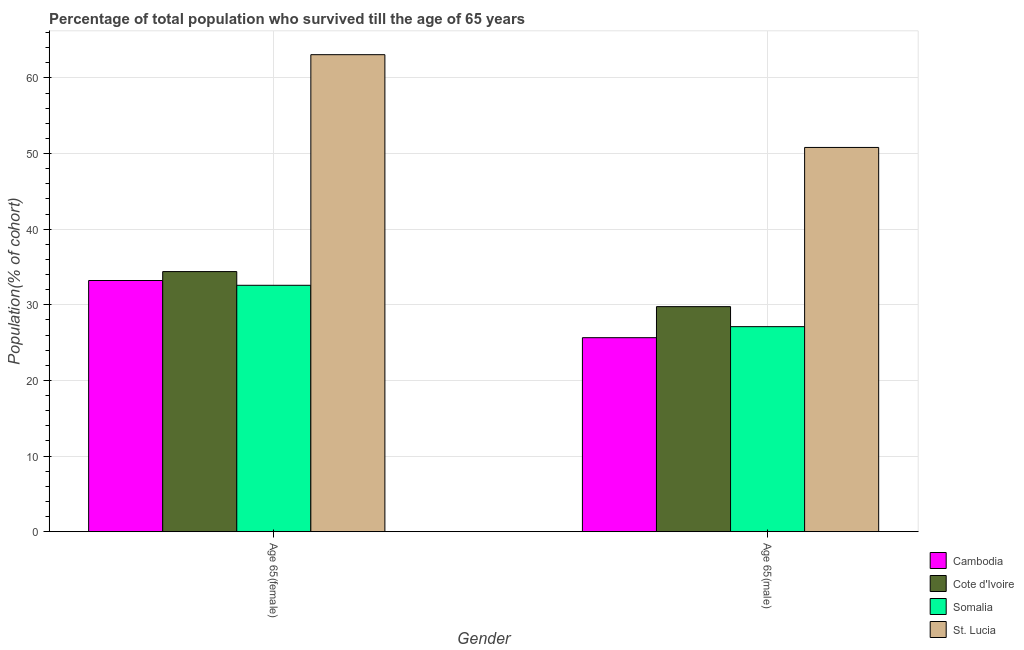How many different coloured bars are there?
Offer a very short reply. 4. Are the number of bars on each tick of the X-axis equal?
Your response must be concise. Yes. What is the label of the 2nd group of bars from the left?
Offer a terse response. Age 65(male). What is the percentage of female population who survived till age of 65 in Somalia?
Keep it short and to the point. 32.58. Across all countries, what is the maximum percentage of male population who survived till age of 65?
Your answer should be compact. 50.8. Across all countries, what is the minimum percentage of female population who survived till age of 65?
Provide a short and direct response. 32.58. In which country was the percentage of female population who survived till age of 65 maximum?
Offer a terse response. St. Lucia. In which country was the percentage of female population who survived till age of 65 minimum?
Offer a very short reply. Somalia. What is the total percentage of female population who survived till age of 65 in the graph?
Your answer should be very brief. 163.25. What is the difference between the percentage of male population who survived till age of 65 in Cambodia and that in St. Lucia?
Provide a short and direct response. -25.15. What is the difference between the percentage of female population who survived till age of 65 in St. Lucia and the percentage of male population who survived till age of 65 in Cambodia?
Keep it short and to the point. 37.42. What is the average percentage of female population who survived till age of 65 per country?
Your answer should be compact. 40.81. What is the difference between the percentage of female population who survived till age of 65 and percentage of male population who survived till age of 65 in St. Lucia?
Offer a terse response. 12.26. What is the ratio of the percentage of female population who survived till age of 65 in Cambodia to that in St. Lucia?
Your answer should be very brief. 0.53. In how many countries, is the percentage of male population who survived till age of 65 greater than the average percentage of male population who survived till age of 65 taken over all countries?
Keep it short and to the point. 1. What does the 1st bar from the left in Age 65(female) represents?
Keep it short and to the point. Cambodia. What does the 1st bar from the right in Age 65(female) represents?
Give a very brief answer. St. Lucia. Are all the bars in the graph horizontal?
Your response must be concise. No. What is the difference between two consecutive major ticks on the Y-axis?
Ensure brevity in your answer.  10. Does the graph contain any zero values?
Make the answer very short. No. Where does the legend appear in the graph?
Your response must be concise. Bottom right. How are the legend labels stacked?
Offer a terse response. Vertical. What is the title of the graph?
Keep it short and to the point. Percentage of total population who survived till the age of 65 years. What is the label or title of the Y-axis?
Provide a succinct answer. Population(% of cohort). What is the Population(% of cohort) of Cambodia in Age 65(female)?
Give a very brief answer. 33.21. What is the Population(% of cohort) in Cote d'Ivoire in Age 65(female)?
Give a very brief answer. 34.39. What is the Population(% of cohort) of Somalia in Age 65(female)?
Provide a short and direct response. 32.58. What is the Population(% of cohort) in St. Lucia in Age 65(female)?
Your answer should be compact. 63.07. What is the Population(% of cohort) of Cambodia in Age 65(male)?
Your response must be concise. 25.65. What is the Population(% of cohort) in Cote d'Ivoire in Age 65(male)?
Keep it short and to the point. 29.76. What is the Population(% of cohort) of Somalia in Age 65(male)?
Make the answer very short. 27.11. What is the Population(% of cohort) in St. Lucia in Age 65(male)?
Provide a short and direct response. 50.8. Across all Gender, what is the maximum Population(% of cohort) in Cambodia?
Your answer should be compact. 33.21. Across all Gender, what is the maximum Population(% of cohort) of Cote d'Ivoire?
Keep it short and to the point. 34.39. Across all Gender, what is the maximum Population(% of cohort) in Somalia?
Your response must be concise. 32.58. Across all Gender, what is the maximum Population(% of cohort) in St. Lucia?
Provide a short and direct response. 63.07. Across all Gender, what is the minimum Population(% of cohort) in Cambodia?
Provide a short and direct response. 25.65. Across all Gender, what is the minimum Population(% of cohort) of Cote d'Ivoire?
Make the answer very short. 29.76. Across all Gender, what is the minimum Population(% of cohort) of Somalia?
Give a very brief answer. 27.11. Across all Gender, what is the minimum Population(% of cohort) in St. Lucia?
Give a very brief answer. 50.8. What is the total Population(% of cohort) of Cambodia in the graph?
Give a very brief answer. 58.86. What is the total Population(% of cohort) of Cote d'Ivoire in the graph?
Keep it short and to the point. 64.15. What is the total Population(% of cohort) of Somalia in the graph?
Give a very brief answer. 59.69. What is the total Population(% of cohort) of St. Lucia in the graph?
Provide a short and direct response. 113.87. What is the difference between the Population(% of cohort) in Cambodia in Age 65(female) and that in Age 65(male)?
Keep it short and to the point. 7.56. What is the difference between the Population(% of cohort) in Cote d'Ivoire in Age 65(female) and that in Age 65(male)?
Your answer should be very brief. 4.63. What is the difference between the Population(% of cohort) of Somalia in Age 65(female) and that in Age 65(male)?
Provide a short and direct response. 5.47. What is the difference between the Population(% of cohort) in St. Lucia in Age 65(female) and that in Age 65(male)?
Offer a terse response. 12.27. What is the difference between the Population(% of cohort) in Cambodia in Age 65(female) and the Population(% of cohort) in Cote d'Ivoire in Age 65(male)?
Your answer should be compact. 3.46. What is the difference between the Population(% of cohort) of Cambodia in Age 65(female) and the Population(% of cohort) of Somalia in Age 65(male)?
Offer a very short reply. 6.1. What is the difference between the Population(% of cohort) in Cambodia in Age 65(female) and the Population(% of cohort) in St. Lucia in Age 65(male)?
Give a very brief answer. -17.59. What is the difference between the Population(% of cohort) of Cote d'Ivoire in Age 65(female) and the Population(% of cohort) of Somalia in Age 65(male)?
Your response must be concise. 7.28. What is the difference between the Population(% of cohort) in Cote d'Ivoire in Age 65(female) and the Population(% of cohort) in St. Lucia in Age 65(male)?
Offer a terse response. -16.41. What is the difference between the Population(% of cohort) in Somalia in Age 65(female) and the Population(% of cohort) in St. Lucia in Age 65(male)?
Your response must be concise. -18.22. What is the average Population(% of cohort) in Cambodia per Gender?
Ensure brevity in your answer.  29.43. What is the average Population(% of cohort) in Cote d'Ivoire per Gender?
Offer a terse response. 32.07. What is the average Population(% of cohort) in Somalia per Gender?
Your response must be concise. 29.85. What is the average Population(% of cohort) of St. Lucia per Gender?
Your response must be concise. 56.94. What is the difference between the Population(% of cohort) of Cambodia and Population(% of cohort) of Cote d'Ivoire in Age 65(female)?
Keep it short and to the point. -1.18. What is the difference between the Population(% of cohort) of Cambodia and Population(% of cohort) of Somalia in Age 65(female)?
Your answer should be compact. 0.63. What is the difference between the Population(% of cohort) of Cambodia and Population(% of cohort) of St. Lucia in Age 65(female)?
Your answer should be compact. -29.86. What is the difference between the Population(% of cohort) in Cote d'Ivoire and Population(% of cohort) in Somalia in Age 65(female)?
Ensure brevity in your answer.  1.81. What is the difference between the Population(% of cohort) in Cote d'Ivoire and Population(% of cohort) in St. Lucia in Age 65(female)?
Your answer should be compact. -28.68. What is the difference between the Population(% of cohort) in Somalia and Population(% of cohort) in St. Lucia in Age 65(female)?
Keep it short and to the point. -30.49. What is the difference between the Population(% of cohort) in Cambodia and Population(% of cohort) in Cote d'Ivoire in Age 65(male)?
Your answer should be very brief. -4.1. What is the difference between the Population(% of cohort) in Cambodia and Population(% of cohort) in Somalia in Age 65(male)?
Make the answer very short. -1.46. What is the difference between the Population(% of cohort) in Cambodia and Population(% of cohort) in St. Lucia in Age 65(male)?
Ensure brevity in your answer.  -25.15. What is the difference between the Population(% of cohort) of Cote d'Ivoire and Population(% of cohort) of Somalia in Age 65(male)?
Provide a short and direct response. 2.65. What is the difference between the Population(% of cohort) of Cote d'Ivoire and Population(% of cohort) of St. Lucia in Age 65(male)?
Your response must be concise. -21.05. What is the difference between the Population(% of cohort) in Somalia and Population(% of cohort) in St. Lucia in Age 65(male)?
Ensure brevity in your answer.  -23.69. What is the ratio of the Population(% of cohort) of Cambodia in Age 65(female) to that in Age 65(male)?
Keep it short and to the point. 1.29. What is the ratio of the Population(% of cohort) of Cote d'Ivoire in Age 65(female) to that in Age 65(male)?
Give a very brief answer. 1.16. What is the ratio of the Population(% of cohort) of Somalia in Age 65(female) to that in Age 65(male)?
Your answer should be very brief. 1.2. What is the ratio of the Population(% of cohort) of St. Lucia in Age 65(female) to that in Age 65(male)?
Provide a short and direct response. 1.24. What is the difference between the highest and the second highest Population(% of cohort) in Cambodia?
Your answer should be compact. 7.56. What is the difference between the highest and the second highest Population(% of cohort) of Cote d'Ivoire?
Offer a very short reply. 4.63. What is the difference between the highest and the second highest Population(% of cohort) of Somalia?
Provide a succinct answer. 5.47. What is the difference between the highest and the second highest Population(% of cohort) of St. Lucia?
Provide a succinct answer. 12.27. What is the difference between the highest and the lowest Population(% of cohort) of Cambodia?
Provide a short and direct response. 7.56. What is the difference between the highest and the lowest Population(% of cohort) in Cote d'Ivoire?
Offer a very short reply. 4.63. What is the difference between the highest and the lowest Population(% of cohort) in Somalia?
Your answer should be compact. 5.47. What is the difference between the highest and the lowest Population(% of cohort) of St. Lucia?
Your answer should be very brief. 12.27. 